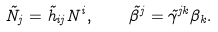<formula> <loc_0><loc_0><loc_500><loc_500>\tilde { N } _ { j } = \tilde { h } _ { i j } N ^ { i } , \quad \tilde { \beta } ^ { j } = \tilde { \gamma } ^ { j k } \beta _ { k } .</formula> 